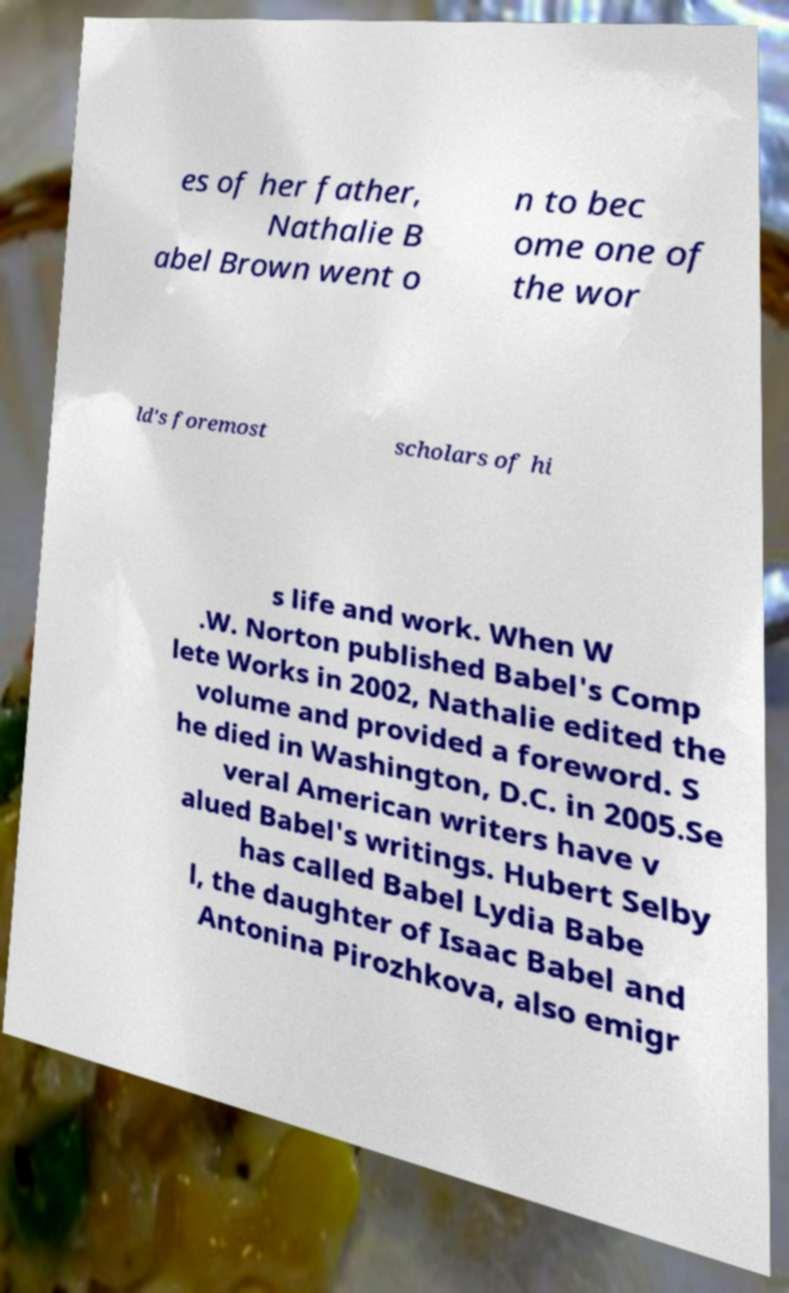There's text embedded in this image that I need extracted. Can you transcribe it verbatim? es of her father, Nathalie B abel Brown went o n to bec ome one of the wor ld's foremost scholars of hi s life and work. When W .W. Norton published Babel's Comp lete Works in 2002, Nathalie edited the volume and provided a foreword. S he died in Washington, D.C. in 2005.Se veral American writers have v alued Babel's writings. Hubert Selby has called Babel Lydia Babe l, the daughter of Isaac Babel and Antonina Pirozhkova, also emigr 